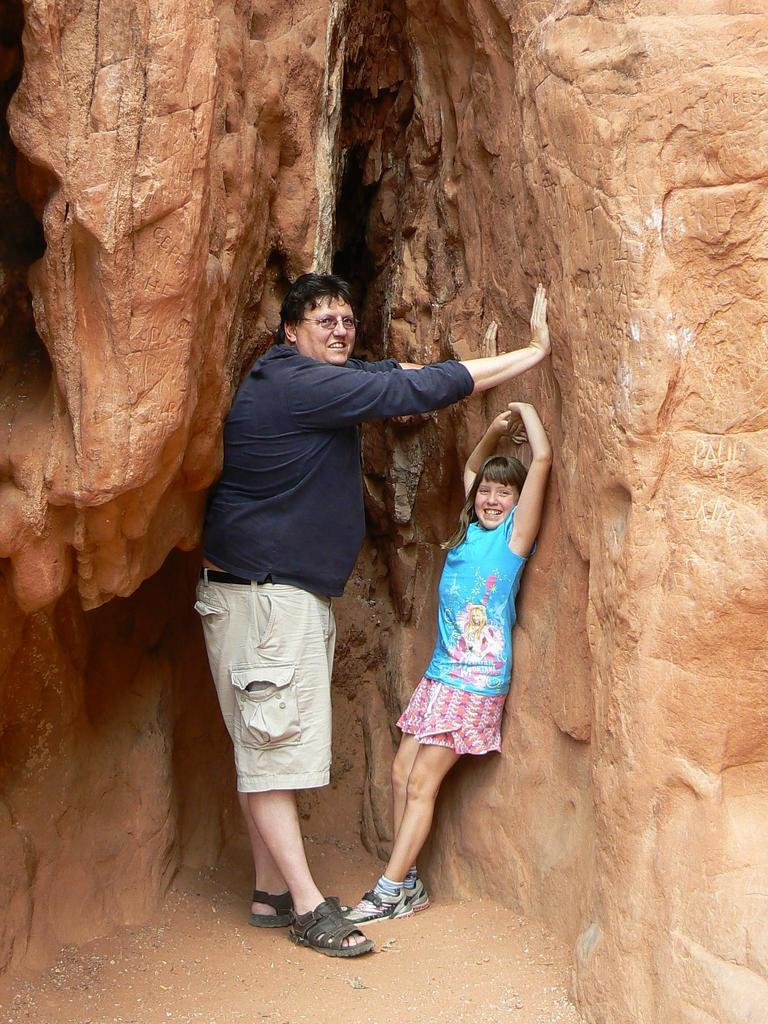Who are the people in the image? There is a man and a girl in the image. What are the man and the girl doing in the image? Both the man and the girl are standing and smiling. Where are the man and the girl standing? They are standing between rocks. What type of surface is visible at the bottom of the image? There is sand visible at the bottom of the image. What type of bag is the man carrying on his wheel in the image? There is no bag or wheel present in the image; the man and the girl are standing between rocks with no visible bags or wheels. 